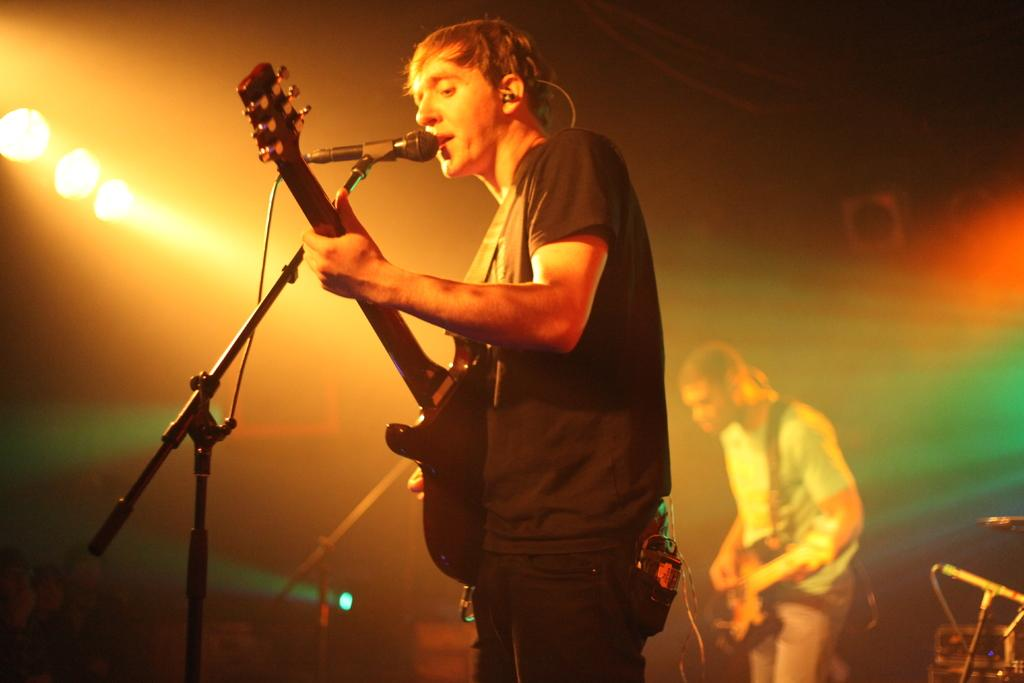Who is the main subject in the image? There is a man in the image. What is the man doing in the image? The man is standing in front of a microphone and playing a guitar. What can be seen in the background of the image? There are lights visible in the image. What is the title of the song the man is singing in the image? There is no indication in the image that the man is singing, and therefore no song title can be determined. 